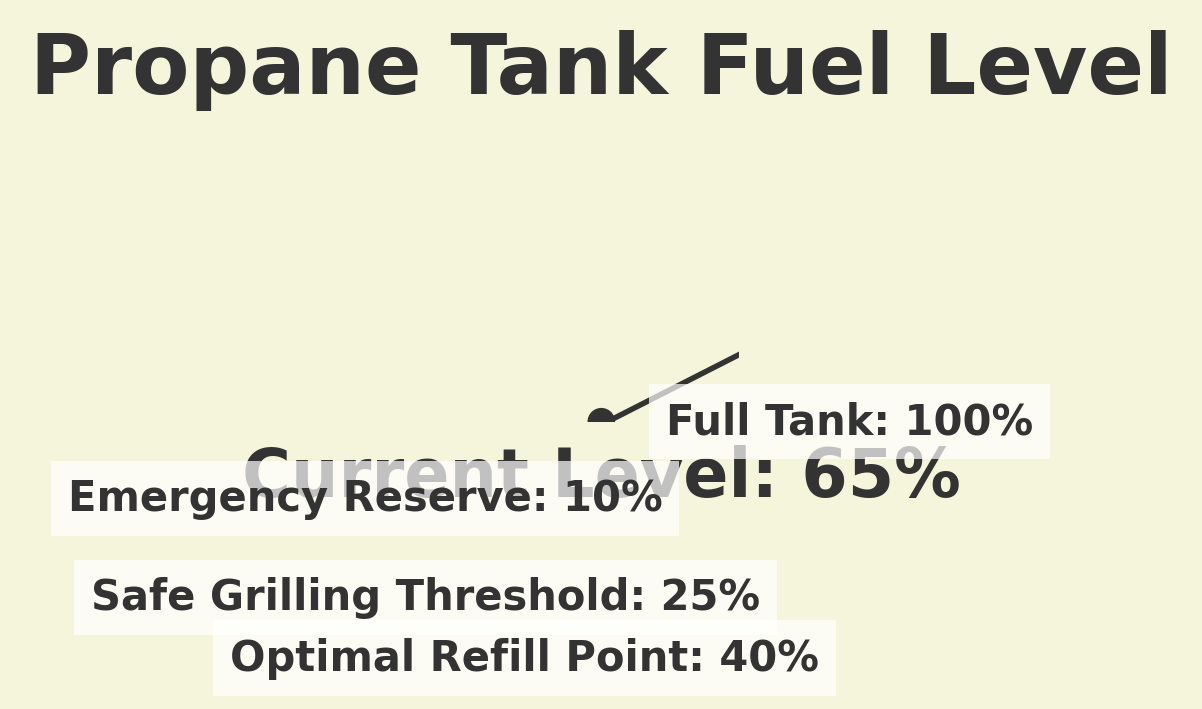What's the title of the gauge chart? The title is usually located at the top of the figure. Look above the central gauge to find the bold section labeled "Propane Tank Fuel Level".
Answer: Propane Tank Fuel Level What's the current propane level percentage shown on the gauge? The percentage is displayed both visually by the needle and textually beneath the gauge. The label explicitly states "Current Level: 65%".
Answer: 65% Between which two percentages is the needle pointing? The needle's angle can be interpolated between two percentage levels directly on the gauge. The needle points to 65%, which visually falls between the "Optimal Refill Point" (40%) and below the "Full Tank" (100%).
Answer: 40% and 100% What is the minimum propane level percentage specified on the gauge? The gauge arc starts from the left side labeled with "Emergency Reserve," indicating 10%. Therefore, the start of the gauge - 0% - is the minimum level shown.
Answer: 0% Which level is higher: the "Safe Grilling Threshold" or the "Optimal Refill Point"? Check the labels placed around the arc. The "Safe Grilling Threshold" is labeled at 25%, while the "Optimal Refill Point" is labeled at 40%. Thus, the "Optimal Refill Point" is higher.
Answer: Optimal Refill Point What is the difference between the "Full Tank" level and the "Current Propane Level"? Subtract the "Current Propane Level" (which is 65%) from the "Full Tank" level (100%). 100% - 65% = 35%.
Answer: 35% How much propane level is above the "Emergency Reserve"? The "Emergency Reserve" is labeled at 10%, and the "Current Propane Level" is at 65%. Thus, the propane level above the "Emergency Reserve" is 65% - 10% = 55%.
Answer: 55% If the propane level drops to 30%, will it still be above the "Safe Grilling Threshold"? The "Safe Grilling Threshold" is at 25%. Since 30% is higher than 25%, it will still be above this threshold.
Answer: Yes What percentage is shown for the "Full Tank" level? The "Full Tank" label on the gauge indicates 100%.
Answer: 100% Is the propane level closer to being completely full or entirely empty? The current level is at 65%, which is closer to 100% (full) than to 0% (empty). Thus, it is closer to being full.
Answer: Closer to full 